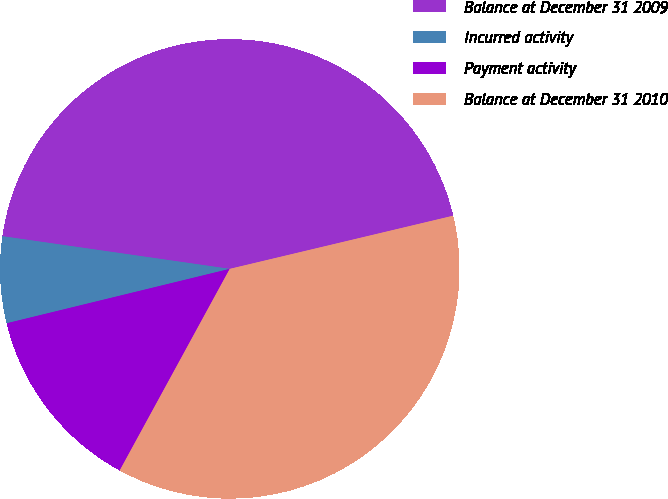Convert chart to OTSL. <chart><loc_0><loc_0><loc_500><loc_500><pie_chart><fcel>Balance at December 31 2009<fcel>Incurred activity<fcel>Payment activity<fcel>Balance at December 31 2010<nl><fcel>44.01%<fcel>6.08%<fcel>13.24%<fcel>36.67%<nl></chart> 